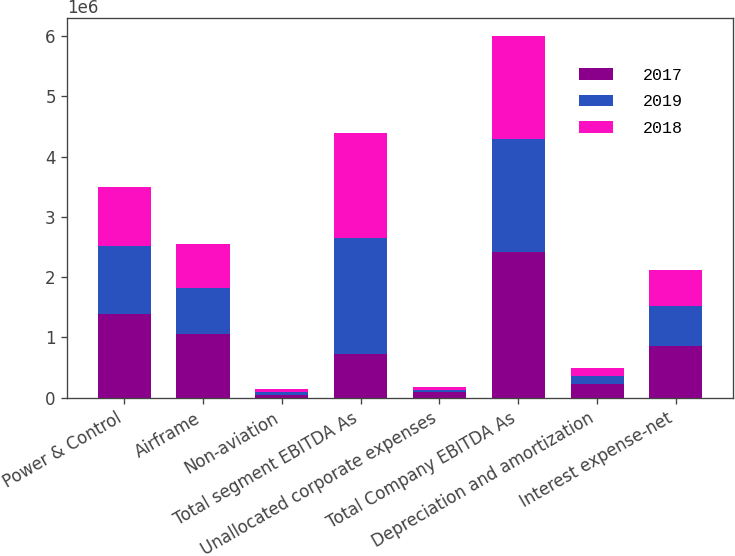Convert chart to OTSL. <chart><loc_0><loc_0><loc_500><loc_500><stacked_bar_chart><ecel><fcel>Power & Control<fcel>Airframe<fcel>Non-aviation<fcel>Total segment EBITDA As<fcel>Unallocated corporate expenses<fcel>Total Company EBITDA As<fcel>Depreciation and amortization<fcel>Interest expense-net<nl><fcel>2017<fcel>1.39508e+06<fcel>1.06268e+06<fcel>50575<fcel>726630<fcel>89538<fcel>2.4188e+06<fcel>225700<fcel>859753<nl><fcel>2019<fcel>1.11446e+06<fcel>759253<fcel>44310<fcel>1.91803e+06<fcel>41469<fcel>1.87656e+06<fcel>129844<fcel>663008<nl><fcel>2018<fcel>980046<fcel>726630<fcel>42475<fcel>1.74915e+06<fcel>38588<fcel>1.71056e+06<fcel>141025<fcel>602589<nl></chart> 